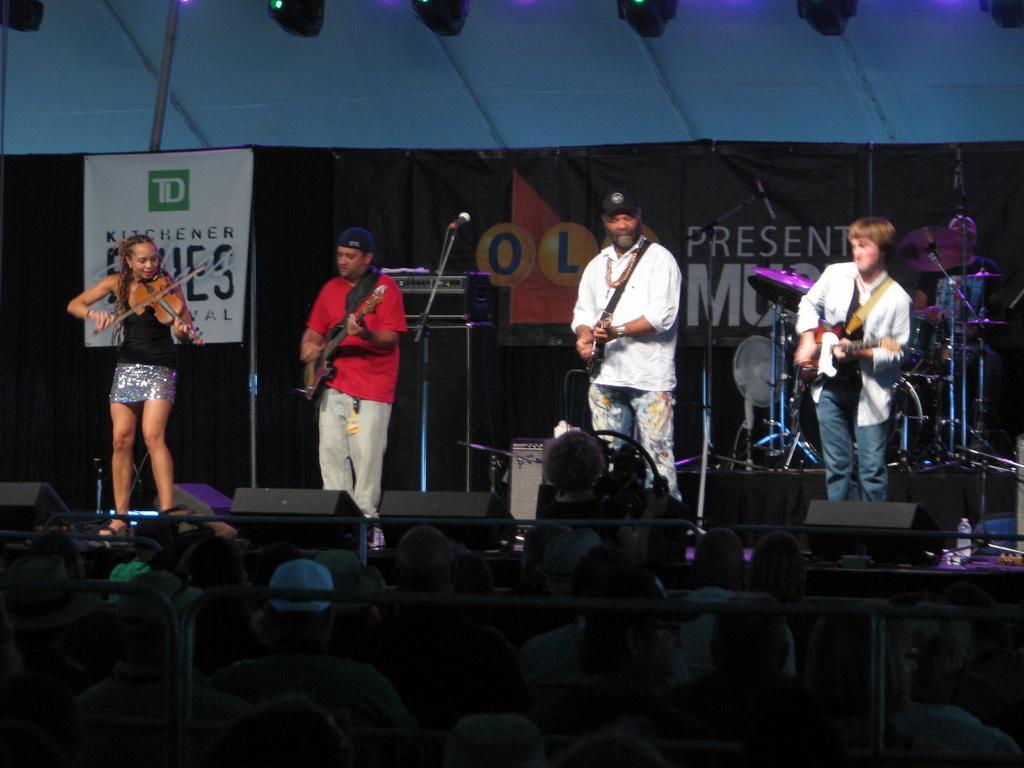Describe this image in one or two sentences. In this picture we can see there are four people standing on the stage and holding musical instruments. In front of the stage there is a group of people and iron rods. Behind the people there are some musical instruments, banners and microphones with stands. At the top there are lights. 